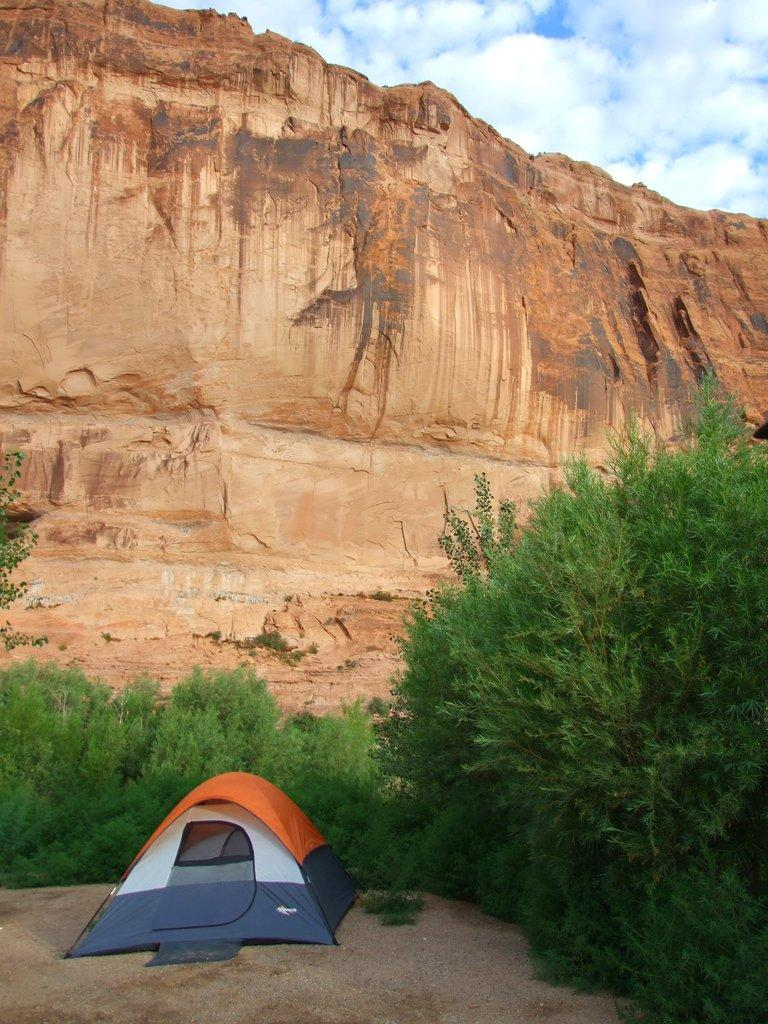What type of shelter is visible in the image? There is a tent in the image. What type of natural vegetation can be seen in the image? There are trees in the image. What can be seen in the distance in the background of the image? There are hills visible in the background of the image. What is visible in the sky in the background of the image? Clouds are present in the sky in the background of the image. What type of jam is being served on the table in the image? There is no table or jam present in the image; it features a tent, trees, hills, and clouds. What type of medical advice is being given in the image? There is no doctor or medical advice present in the image; it features a tent, trees, hills, and clouds. 